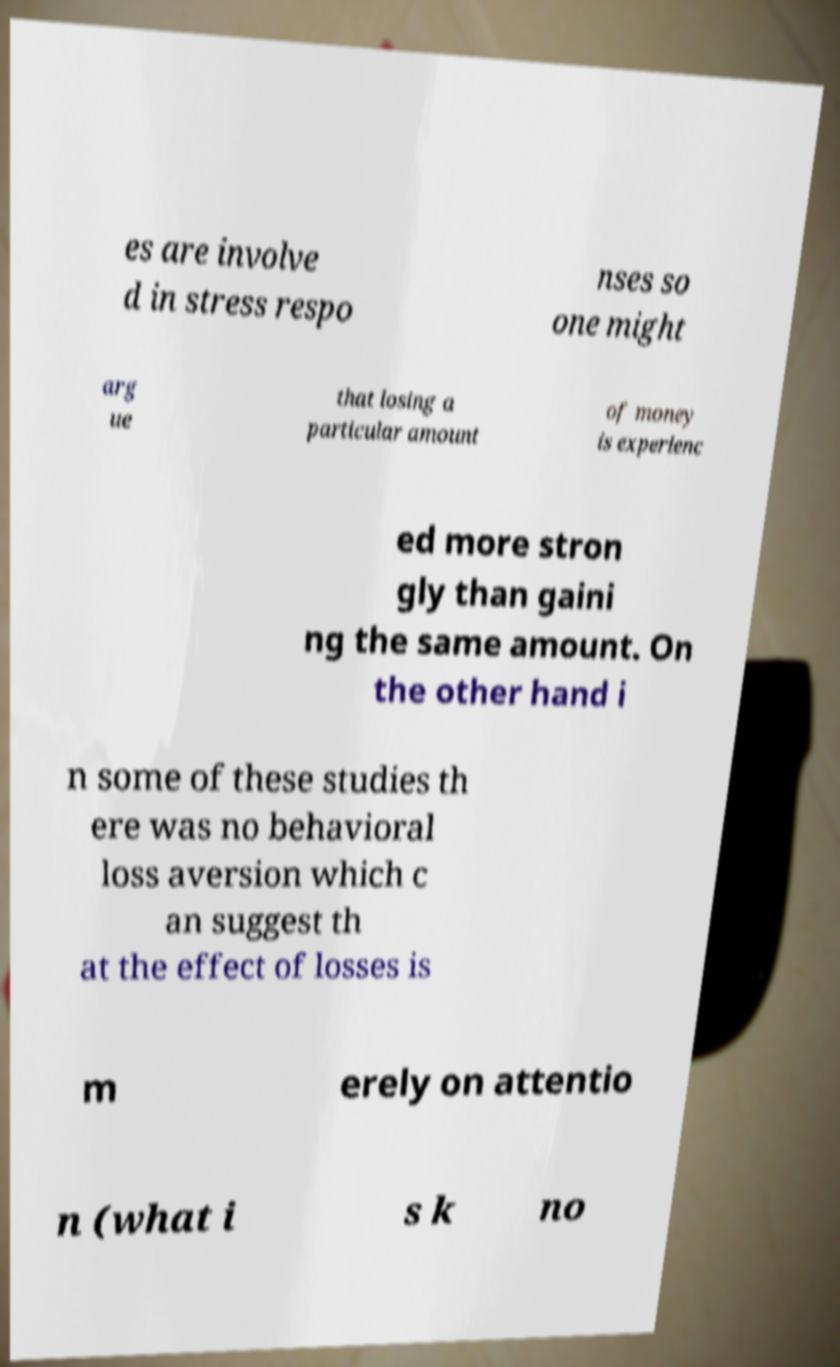What messages or text are displayed in this image? I need them in a readable, typed format. es are involve d in stress respo nses so one might arg ue that losing a particular amount of money is experienc ed more stron gly than gaini ng the same amount. On the other hand i n some of these studies th ere was no behavioral loss aversion which c an suggest th at the effect of losses is m erely on attentio n (what i s k no 